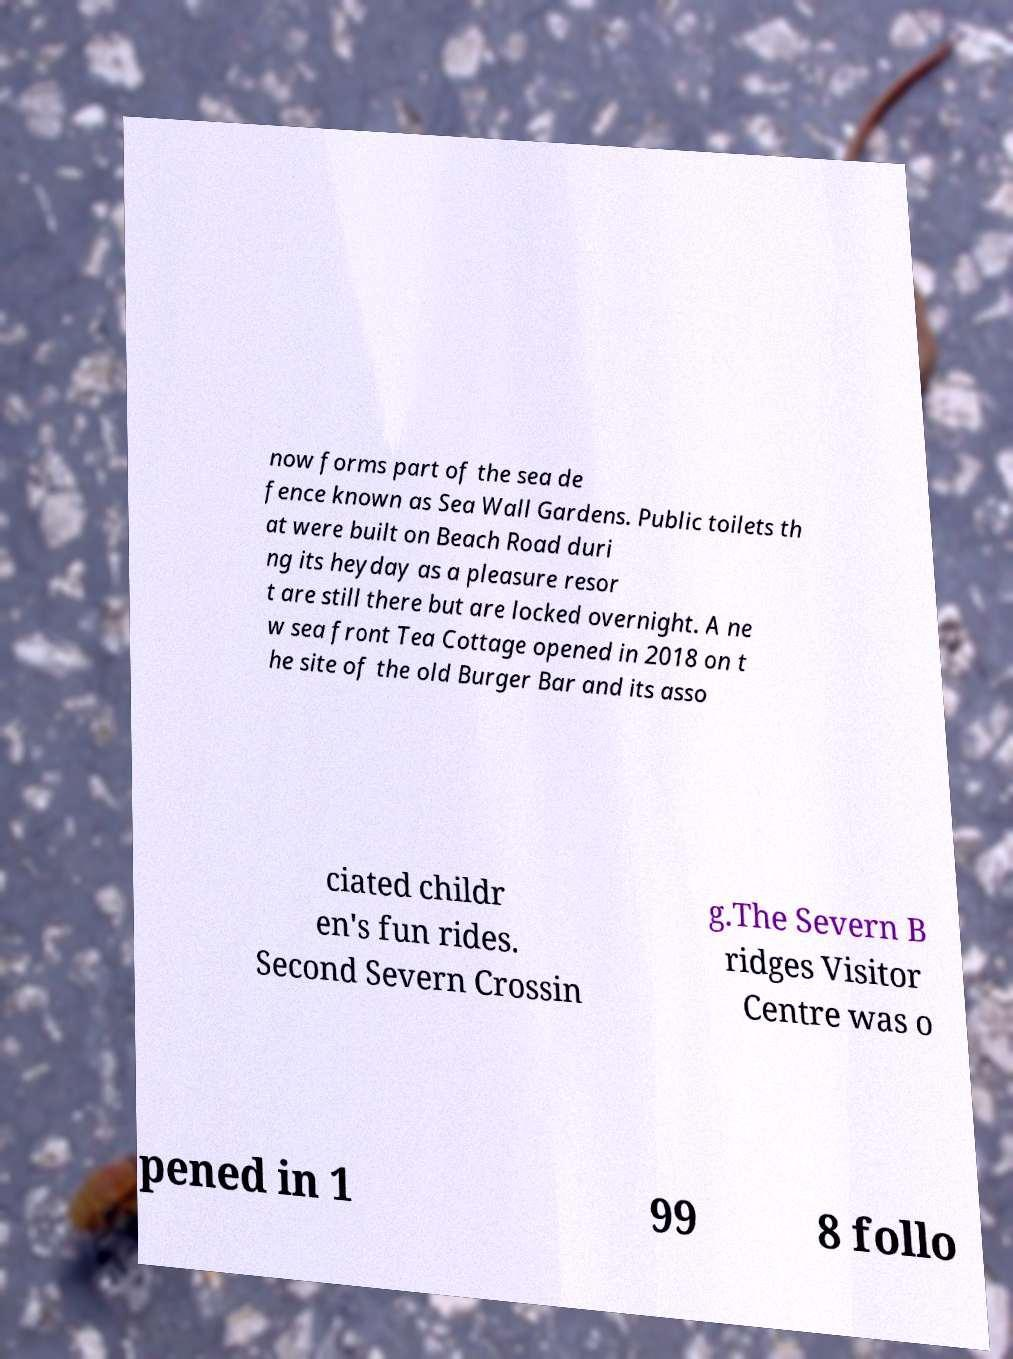Can you read and provide the text displayed in the image?This photo seems to have some interesting text. Can you extract and type it out for me? now forms part of the sea de fence known as Sea Wall Gardens. Public toilets th at were built on Beach Road duri ng its heyday as a pleasure resor t are still there but are locked overnight. A ne w sea front Tea Cottage opened in 2018 on t he site of the old Burger Bar and its asso ciated childr en's fun rides. Second Severn Crossin g.The Severn B ridges Visitor Centre was o pened in 1 99 8 follo 